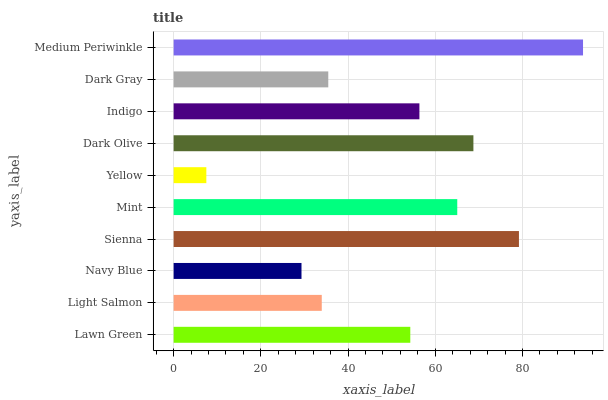Is Yellow the minimum?
Answer yes or no. Yes. Is Medium Periwinkle the maximum?
Answer yes or no. Yes. Is Light Salmon the minimum?
Answer yes or no. No. Is Light Salmon the maximum?
Answer yes or no. No. Is Lawn Green greater than Light Salmon?
Answer yes or no. Yes. Is Light Salmon less than Lawn Green?
Answer yes or no. Yes. Is Light Salmon greater than Lawn Green?
Answer yes or no. No. Is Lawn Green less than Light Salmon?
Answer yes or no. No. Is Indigo the high median?
Answer yes or no. Yes. Is Lawn Green the low median?
Answer yes or no. Yes. Is Medium Periwinkle the high median?
Answer yes or no. No. Is Dark Olive the low median?
Answer yes or no. No. 